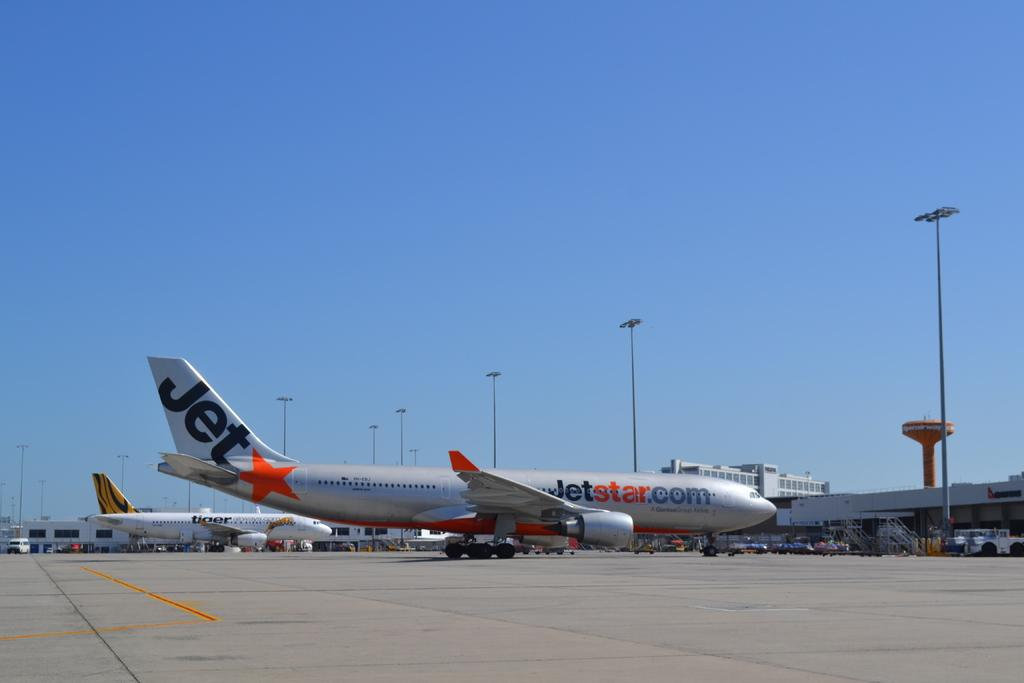Provide a one-sentence caption for the provided image. the jetstar.com plane is sitting at the airport. 